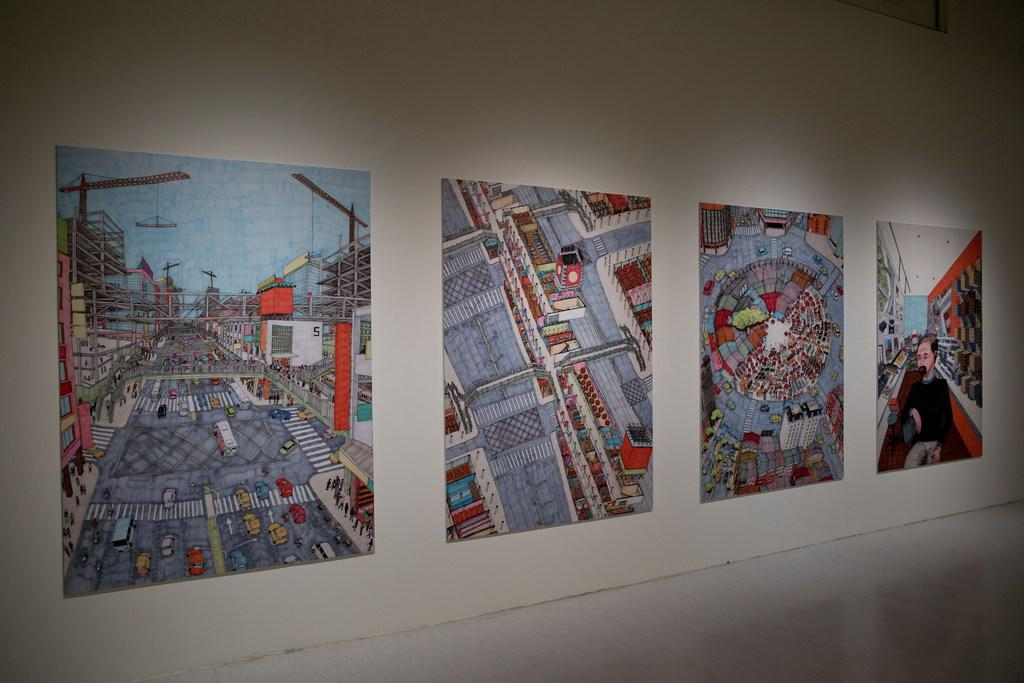What can be seen in the image? There is a wall in the image. Are there any additional features on the wall? Yes, there are posts on the wall. What type of marble is used to decorate the wall in the image? There is no marble present in the image; it only features a wall with posts. How is the string used in the image? There is no string present in the image. 